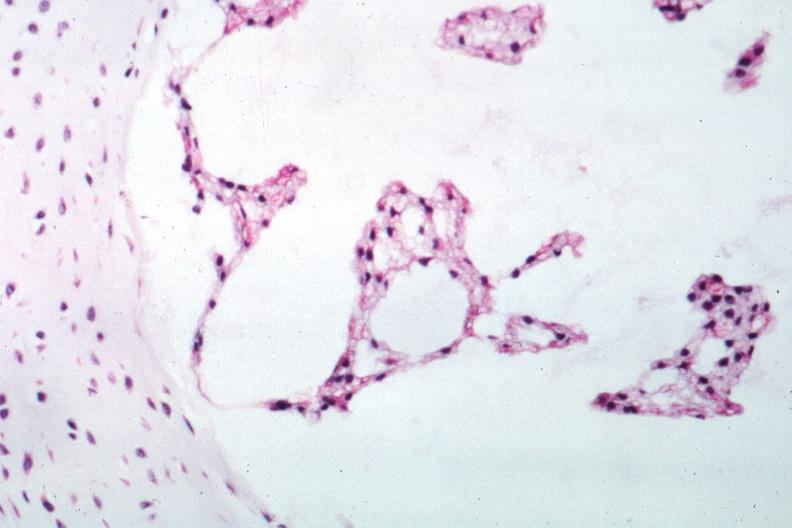s notochord present?
Answer the question using a single word or phrase. Yes 